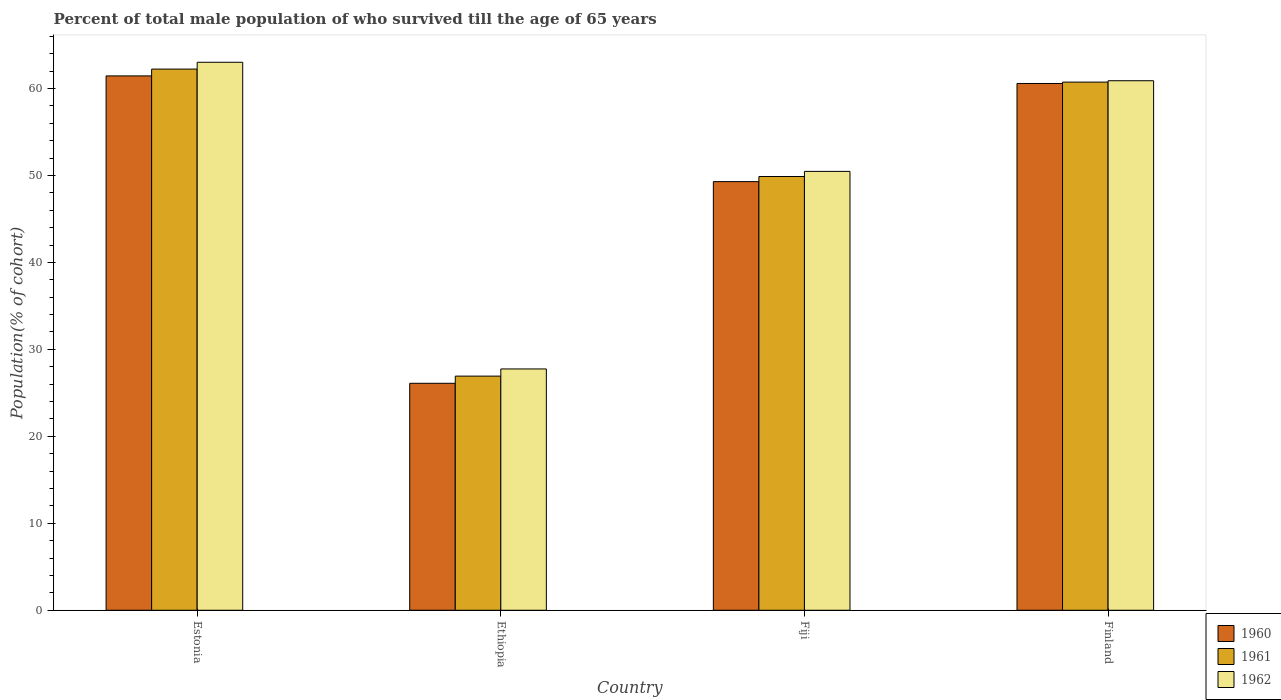How many different coloured bars are there?
Ensure brevity in your answer.  3. Are the number of bars per tick equal to the number of legend labels?
Keep it short and to the point. Yes. How many bars are there on the 3rd tick from the right?
Give a very brief answer. 3. In how many cases, is the number of bars for a given country not equal to the number of legend labels?
Offer a very short reply. 0. What is the percentage of total male population who survived till the age of 65 years in 1961 in Finland?
Provide a succinct answer. 60.73. Across all countries, what is the maximum percentage of total male population who survived till the age of 65 years in 1961?
Your answer should be very brief. 62.23. Across all countries, what is the minimum percentage of total male population who survived till the age of 65 years in 1961?
Make the answer very short. 26.92. In which country was the percentage of total male population who survived till the age of 65 years in 1962 maximum?
Make the answer very short. Estonia. In which country was the percentage of total male population who survived till the age of 65 years in 1962 minimum?
Your answer should be very brief. Ethiopia. What is the total percentage of total male population who survived till the age of 65 years in 1960 in the graph?
Give a very brief answer. 197.41. What is the difference between the percentage of total male population who survived till the age of 65 years in 1962 in Estonia and that in Fiji?
Provide a short and direct response. 12.55. What is the difference between the percentage of total male population who survived till the age of 65 years in 1960 in Ethiopia and the percentage of total male population who survived till the age of 65 years in 1961 in Estonia?
Your response must be concise. -36.13. What is the average percentage of total male population who survived till the age of 65 years in 1960 per country?
Make the answer very short. 49.35. What is the difference between the percentage of total male population who survived till the age of 65 years of/in 1960 and percentage of total male population who survived till the age of 65 years of/in 1961 in Fiji?
Your answer should be compact. -0.59. What is the ratio of the percentage of total male population who survived till the age of 65 years in 1962 in Estonia to that in Finland?
Make the answer very short. 1.03. What is the difference between the highest and the second highest percentage of total male population who survived till the age of 65 years in 1961?
Offer a terse response. -10.86. What is the difference between the highest and the lowest percentage of total male population who survived till the age of 65 years in 1962?
Ensure brevity in your answer.  35.26. Is the sum of the percentage of total male population who survived till the age of 65 years in 1961 in Fiji and Finland greater than the maximum percentage of total male population who survived till the age of 65 years in 1960 across all countries?
Your response must be concise. Yes. What does the 1st bar from the right in Estonia represents?
Give a very brief answer. 1962. Is it the case that in every country, the sum of the percentage of total male population who survived till the age of 65 years in 1960 and percentage of total male population who survived till the age of 65 years in 1962 is greater than the percentage of total male population who survived till the age of 65 years in 1961?
Provide a short and direct response. Yes. How many countries are there in the graph?
Keep it short and to the point. 4. Does the graph contain any zero values?
Provide a succinct answer. No. Does the graph contain grids?
Offer a terse response. No. How are the legend labels stacked?
Your answer should be very brief. Vertical. What is the title of the graph?
Your answer should be very brief. Percent of total male population of who survived till the age of 65 years. What is the label or title of the Y-axis?
Provide a succinct answer. Population(% of cohort). What is the Population(% of cohort) in 1960 in Estonia?
Offer a terse response. 61.45. What is the Population(% of cohort) in 1961 in Estonia?
Offer a very short reply. 62.23. What is the Population(% of cohort) of 1962 in Estonia?
Your answer should be compact. 63.01. What is the Population(% of cohort) of 1960 in Ethiopia?
Ensure brevity in your answer.  26.1. What is the Population(% of cohort) of 1961 in Ethiopia?
Offer a terse response. 26.92. What is the Population(% of cohort) of 1962 in Ethiopia?
Your response must be concise. 27.75. What is the Population(% of cohort) of 1960 in Fiji?
Offer a very short reply. 49.29. What is the Population(% of cohort) in 1961 in Fiji?
Your response must be concise. 49.88. What is the Population(% of cohort) in 1962 in Fiji?
Provide a short and direct response. 50.47. What is the Population(% of cohort) of 1960 in Finland?
Provide a short and direct response. 60.57. What is the Population(% of cohort) in 1961 in Finland?
Your response must be concise. 60.73. What is the Population(% of cohort) of 1962 in Finland?
Give a very brief answer. 60.89. Across all countries, what is the maximum Population(% of cohort) in 1960?
Your answer should be very brief. 61.45. Across all countries, what is the maximum Population(% of cohort) of 1961?
Offer a very short reply. 62.23. Across all countries, what is the maximum Population(% of cohort) of 1962?
Your answer should be compact. 63.01. Across all countries, what is the minimum Population(% of cohort) in 1960?
Your response must be concise. 26.1. Across all countries, what is the minimum Population(% of cohort) of 1961?
Your answer should be compact. 26.92. Across all countries, what is the minimum Population(% of cohort) of 1962?
Your answer should be compact. 27.75. What is the total Population(% of cohort) of 1960 in the graph?
Your response must be concise. 197.41. What is the total Population(% of cohort) in 1961 in the graph?
Provide a short and direct response. 199.76. What is the total Population(% of cohort) of 1962 in the graph?
Your response must be concise. 202.12. What is the difference between the Population(% of cohort) of 1960 in Estonia and that in Ethiopia?
Offer a very short reply. 35.35. What is the difference between the Population(% of cohort) in 1961 in Estonia and that in Ethiopia?
Make the answer very short. 35.3. What is the difference between the Population(% of cohort) in 1962 in Estonia and that in Ethiopia?
Provide a short and direct response. 35.26. What is the difference between the Population(% of cohort) of 1960 in Estonia and that in Fiji?
Provide a short and direct response. 12.16. What is the difference between the Population(% of cohort) in 1961 in Estonia and that in Fiji?
Ensure brevity in your answer.  12.35. What is the difference between the Population(% of cohort) in 1962 in Estonia and that in Fiji?
Provide a short and direct response. 12.55. What is the difference between the Population(% of cohort) in 1960 in Estonia and that in Finland?
Ensure brevity in your answer.  0.87. What is the difference between the Population(% of cohort) of 1961 in Estonia and that in Finland?
Offer a terse response. 1.5. What is the difference between the Population(% of cohort) in 1962 in Estonia and that in Finland?
Your response must be concise. 2.12. What is the difference between the Population(% of cohort) of 1960 in Ethiopia and that in Fiji?
Make the answer very short. -23.19. What is the difference between the Population(% of cohort) of 1961 in Ethiopia and that in Fiji?
Keep it short and to the point. -22.95. What is the difference between the Population(% of cohort) of 1962 in Ethiopia and that in Fiji?
Provide a succinct answer. -22.72. What is the difference between the Population(% of cohort) in 1960 in Ethiopia and that in Finland?
Your answer should be compact. -34.47. What is the difference between the Population(% of cohort) of 1961 in Ethiopia and that in Finland?
Your answer should be compact. -33.81. What is the difference between the Population(% of cohort) of 1962 in Ethiopia and that in Finland?
Ensure brevity in your answer.  -33.14. What is the difference between the Population(% of cohort) of 1960 in Fiji and that in Finland?
Your answer should be very brief. -11.28. What is the difference between the Population(% of cohort) of 1961 in Fiji and that in Finland?
Keep it short and to the point. -10.86. What is the difference between the Population(% of cohort) in 1962 in Fiji and that in Finland?
Ensure brevity in your answer.  -10.43. What is the difference between the Population(% of cohort) of 1960 in Estonia and the Population(% of cohort) of 1961 in Ethiopia?
Provide a short and direct response. 34.52. What is the difference between the Population(% of cohort) in 1960 in Estonia and the Population(% of cohort) in 1962 in Ethiopia?
Give a very brief answer. 33.7. What is the difference between the Population(% of cohort) of 1961 in Estonia and the Population(% of cohort) of 1962 in Ethiopia?
Provide a succinct answer. 34.48. What is the difference between the Population(% of cohort) of 1960 in Estonia and the Population(% of cohort) of 1961 in Fiji?
Your response must be concise. 11.57. What is the difference between the Population(% of cohort) of 1960 in Estonia and the Population(% of cohort) of 1962 in Fiji?
Make the answer very short. 10.98. What is the difference between the Population(% of cohort) of 1961 in Estonia and the Population(% of cohort) of 1962 in Fiji?
Offer a very short reply. 11.76. What is the difference between the Population(% of cohort) in 1960 in Estonia and the Population(% of cohort) in 1961 in Finland?
Offer a very short reply. 0.71. What is the difference between the Population(% of cohort) in 1960 in Estonia and the Population(% of cohort) in 1962 in Finland?
Keep it short and to the point. 0.55. What is the difference between the Population(% of cohort) of 1961 in Estonia and the Population(% of cohort) of 1962 in Finland?
Provide a succinct answer. 1.34. What is the difference between the Population(% of cohort) in 1960 in Ethiopia and the Population(% of cohort) in 1961 in Fiji?
Your answer should be compact. -23.78. What is the difference between the Population(% of cohort) of 1960 in Ethiopia and the Population(% of cohort) of 1962 in Fiji?
Make the answer very short. -24.37. What is the difference between the Population(% of cohort) in 1961 in Ethiopia and the Population(% of cohort) in 1962 in Fiji?
Provide a succinct answer. -23.54. What is the difference between the Population(% of cohort) in 1960 in Ethiopia and the Population(% of cohort) in 1961 in Finland?
Your response must be concise. -34.63. What is the difference between the Population(% of cohort) of 1960 in Ethiopia and the Population(% of cohort) of 1962 in Finland?
Offer a very short reply. -34.79. What is the difference between the Population(% of cohort) in 1961 in Ethiopia and the Population(% of cohort) in 1962 in Finland?
Ensure brevity in your answer.  -33.97. What is the difference between the Population(% of cohort) in 1960 in Fiji and the Population(% of cohort) in 1961 in Finland?
Your response must be concise. -11.44. What is the difference between the Population(% of cohort) in 1960 in Fiji and the Population(% of cohort) in 1962 in Finland?
Your answer should be compact. -11.6. What is the difference between the Population(% of cohort) of 1961 in Fiji and the Population(% of cohort) of 1962 in Finland?
Give a very brief answer. -11.01. What is the average Population(% of cohort) in 1960 per country?
Offer a very short reply. 49.35. What is the average Population(% of cohort) in 1961 per country?
Keep it short and to the point. 49.94. What is the average Population(% of cohort) of 1962 per country?
Offer a very short reply. 50.53. What is the difference between the Population(% of cohort) of 1960 and Population(% of cohort) of 1961 in Estonia?
Provide a succinct answer. -0.78. What is the difference between the Population(% of cohort) in 1960 and Population(% of cohort) in 1962 in Estonia?
Ensure brevity in your answer.  -1.57. What is the difference between the Population(% of cohort) in 1961 and Population(% of cohort) in 1962 in Estonia?
Your answer should be very brief. -0.78. What is the difference between the Population(% of cohort) in 1960 and Population(% of cohort) in 1961 in Ethiopia?
Make the answer very short. -0.82. What is the difference between the Population(% of cohort) in 1960 and Population(% of cohort) in 1962 in Ethiopia?
Provide a succinct answer. -1.65. What is the difference between the Population(% of cohort) of 1961 and Population(% of cohort) of 1962 in Ethiopia?
Provide a succinct answer. -0.82. What is the difference between the Population(% of cohort) of 1960 and Population(% of cohort) of 1961 in Fiji?
Keep it short and to the point. -0.59. What is the difference between the Population(% of cohort) in 1960 and Population(% of cohort) in 1962 in Fiji?
Ensure brevity in your answer.  -1.18. What is the difference between the Population(% of cohort) of 1961 and Population(% of cohort) of 1962 in Fiji?
Give a very brief answer. -0.59. What is the difference between the Population(% of cohort) of 1960 and Population(% of cohort) of 1961 in Finland?
Your answer should be very brief. -0.16. What is the difference between the Population(% of cohort) of 1960 and Population(% of cohort) of 1962 in Finland?
Offer a very short reply. -0.32. What is the difference between the Population(% of cohort) of 1961 and Population(% of cohort) of 1962 in Finland?
Make the answer very short. -0.16. What is the ratio of the Population(% of cohort) in 1960 in Estonia to that in Ethiopia?
Offer a terse response. 2.35. What is the ratio of the Population(% of cohort) in 1961 in Estonia to that in Ethiopia?
Make the answer very short. 2.31. What is the ratio of the Population(% of cohort) in 1962 in Estonia to that in Ethiopia?
Your response must be concise. 2.27. What is the ratio of the Population(% of cohort) in 1960 in Estonia to that in Fiji?
Your response must be concise. 1.25. What is the ratio of the Population(% of cohort) in 1961 in Estonia to that in Fiji?
Offer a terse response. 1.25. What is the ratio of the Population(% of cohort) of 1962 in Estonia to that in Fiji?
Your answer should be very brief. 1.25. What is the ratio of the Population(% of cohort) of 1960 in Estonia to that in Finland?
Provide a succinct answer. 1.01. What is the ratio of the Population(% of cohort) in 1961 in Estonia to that in Finland?
Provide a short and direct response. 1.02. What is the ratio of the Population(% of cohort) in 1962 in Estonia to that in Finland?
Your response must be concise. 1.03. What is the ratio of the Population(% of cohort) of 1960 in Ethiopia to that in Fiji?
Ensure brevity in your answer.  0.53. What is the ratio of the Population(% of cohort) in 1961 in Ethiopia to that in Fiji?
Provide a short and direct response. 0.54. What is the ratio of the Population(% of cohort) of 1962 in Ethiopia to that in Fiji?
Your response must be concise. 0.55. What is the ratio of the Population(% of cohort) in 1960 in Ethiopia to that in Finland?
Ensure brevity in your answer.  0.43. What is the ratio of the Population(% of cohort) of 1961 in Ethiopia to that in Finland?
Give a very brief answer. 0.44. What is the ratio of the Population(% of cohort) in 1962 in Ethiopia to that in Finland?
Ensure brevity in your answer.  0.46. What is the ratio of the Population(% of cohort) of 1960 in Fiji to that in Finland?
Your answer should be very brief. 0.81. What is the ratio of the Population(% of cohort) in 1961 in Fiji to that in Finland?
Ensure brevity in your answer.  0.82. What is the ratio of the Population(% of cohort) of 1962 in Fiji to that in Finland?
Make the answer very short. 0.83. What is the difference between the highest and the second highest Population(% of cohort) in 1960?
Your answer should be very brief. 0.87. What is the difference between the highest and the second highest Population(% of cohort) of 1961?
Give a very brief answer. 1.5. What is the difference between the highest and the second highest Population(% of cohort) in 1962?
Make the answer very short. 2.12. What is the difference between the highest and the lowest Population(% of cohort) of 1960?
Your response must be concise. 35.35. What is the difference between the highest and the lowest Population(% of cohort) in 1961?
Ensure brevity in your answer.  35.3. What is the difference between the highest and the lowest Population(% of cohort) of 1962?
Your answer should be compact. 35.26. 